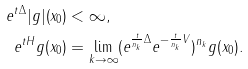<formula> <loc_0><loc_0><loc_500><loc_500>e ^ { t \Delta } | g | ( x _ { 0 } ) & < \infty , \\ e ^ { t H } g ( x _ { 0 } ) & = \lim _ { k \to \infty } ( e ^ { \frac { t } { n _ { k } } \Delta } e ^ { - \frac { t } { n _ { k } } V } ) ^ { n _ { k } } g ( x _ { 0 } ) .</formula> 